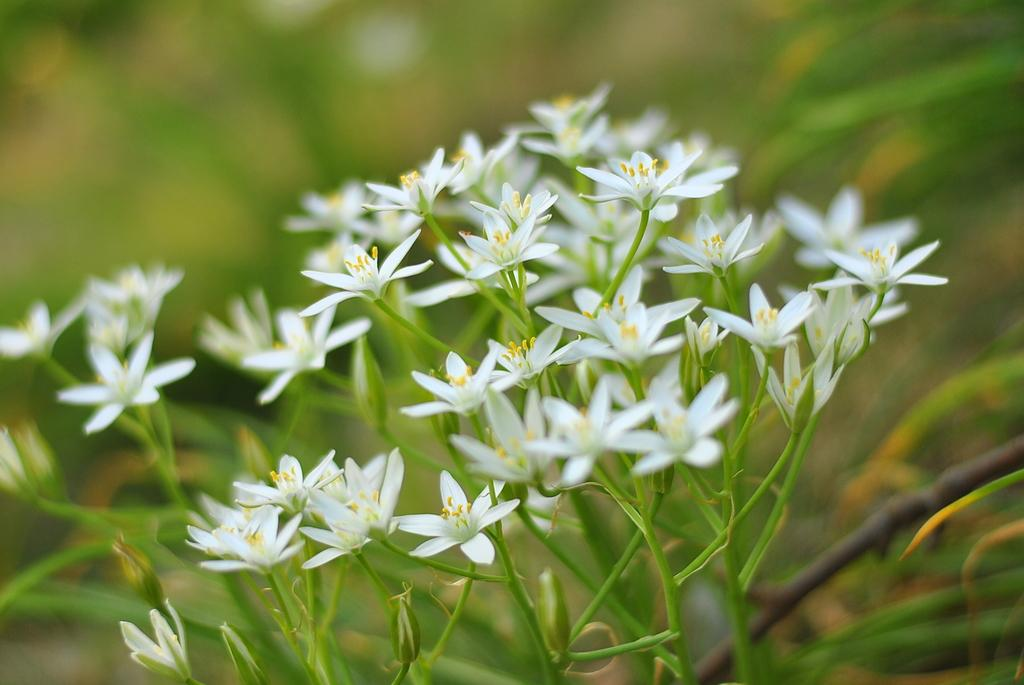What color are the flowers in the image? The flowers in the image are white. What is the color of the flower buds in the image? The flower buds in the image are yellow. What type of plant do these flowers belong to? These flowers belong to a plant. What can be seen in the background of the image? There are other plants visible in the background of the image. What shape is the kettle in the image? There is no kettle present in the image. What subject is the teacher teaching in the image? There is no teaching or teacher present in the image. 